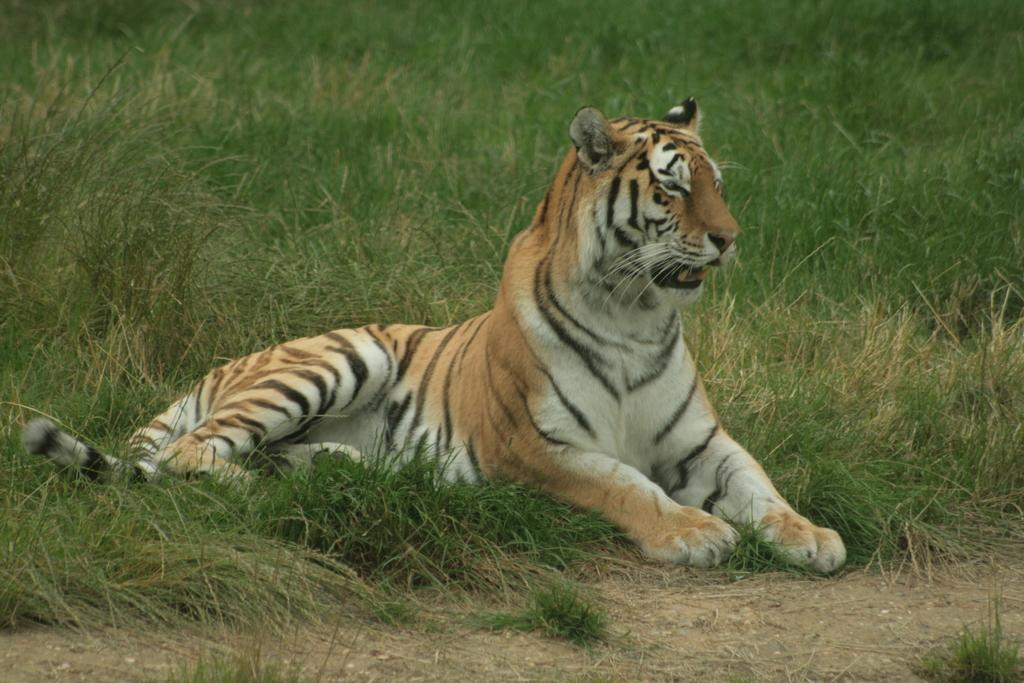What type of animal is in the image? There is a tiger in the image. Where is the tiger located in the image? The tiger is on the ground. What can be seen in the background of the image? There is grass visible in the background of the image. What type of pan can be seen in the image? There is no pan present in the image. What other animals can be seen interacting with the tiger in the image? There are no other animals visible in the image; only the tiger is present. 